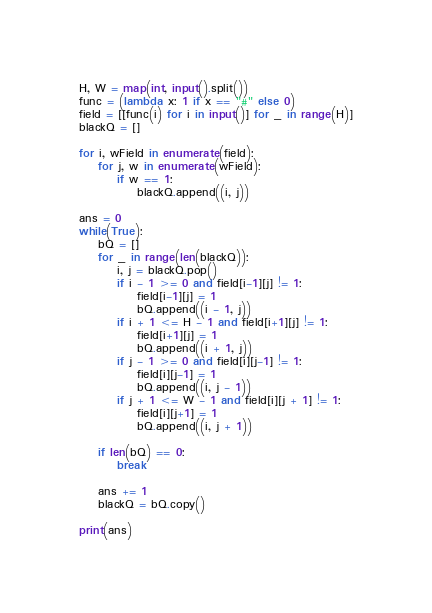<code> <loc_0><loc_0><loc_500><loc_500><_Python_>H, W = map(int, input().split())
func = (lambda x: 1 if x == "#" else 0)
field = [[func(i) for i in input()] for _ in range(H)]
blackQ = []

for i, wField in enumerate(field):
    for j, w in enumerate(wField):
        if w == 1:
            blackQ.append((i, j))

ans = 0
while(True):
    bQ = []
    for _ in range(len(blackQ)):
        i, j = blackQ.pop()
        if i - 1 >= 0 and field[i-1][j] != 1:
            field[i-1][j] = 1
            bQ.append((i - 1, j))
        if i + 1 <= H - 1 and field[i+1][j] != 1:
            field[i+1][j] = 1
            bQ.append((i + 1, j))
        if j - 1 >= 0 and field[i][j-1] != 1:
            field[i][j-1] = 1
            bQ.append((i, j - 1))
        if j + 1 <= W - 1 and field[i][j + 1] != 1:
            field[i][j+1] = 1
            bQ.append((i, j + 1))

    if len(bQ) == 0:
        break

    ans += 1
    blackQ = bQ.copy()

print(ans)

</code> 